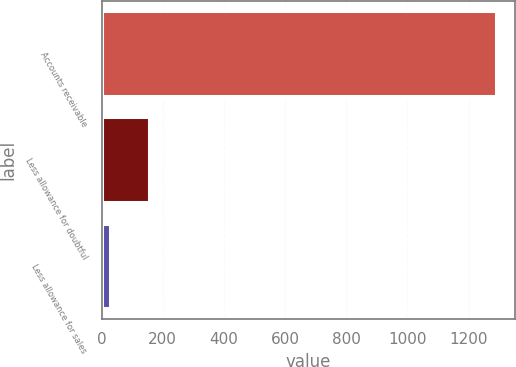Convert chart to OTSL. <chart><loc_0><loc_0><loc_500><loc_500><bar_chart><fcel>Accounts receivable<fcel>Less allowance for doubtful<fcel>Less allowance for sales<nl><fcel>1288<fcel>154.9<fcel>29<nl></chart> 